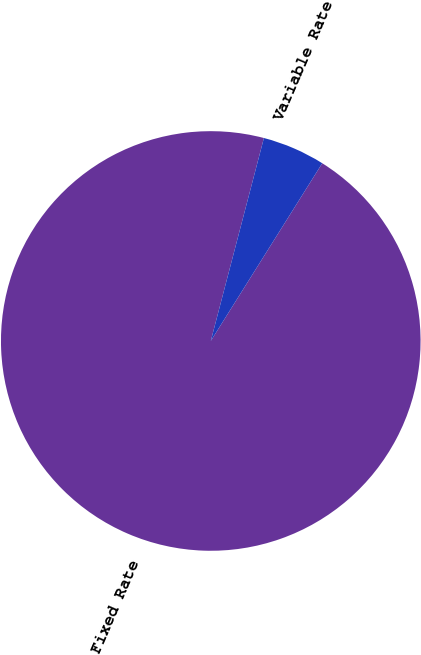<chart> <loc_0><loc_0><loc_500><loc_500><pie_chart><fcel>Fixed Rate<fcel>Variable Rate<nl><fcel>95.16%<fcel>4.84%<nl></chart> 